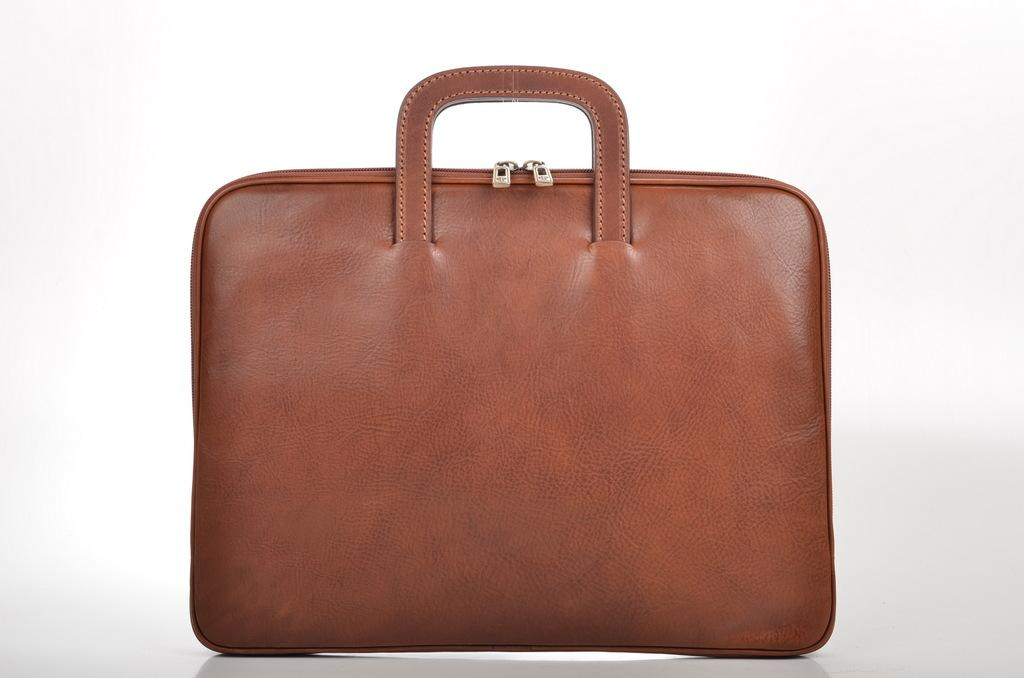What type of bag is visible in the image? There is a leather handbag or a bag in the image. How many zips does the bag have? The bag has two zips. What feature does the bag have for carrying purposes? The bag has a holder. What type of pump can be seen attached to the bag in the image? There is no pump present in the image; it is a leather handbag or a bag with two zips and a holder. How many feathers are visible on the bag in the image? There are no feathers present on the bag in the image. 